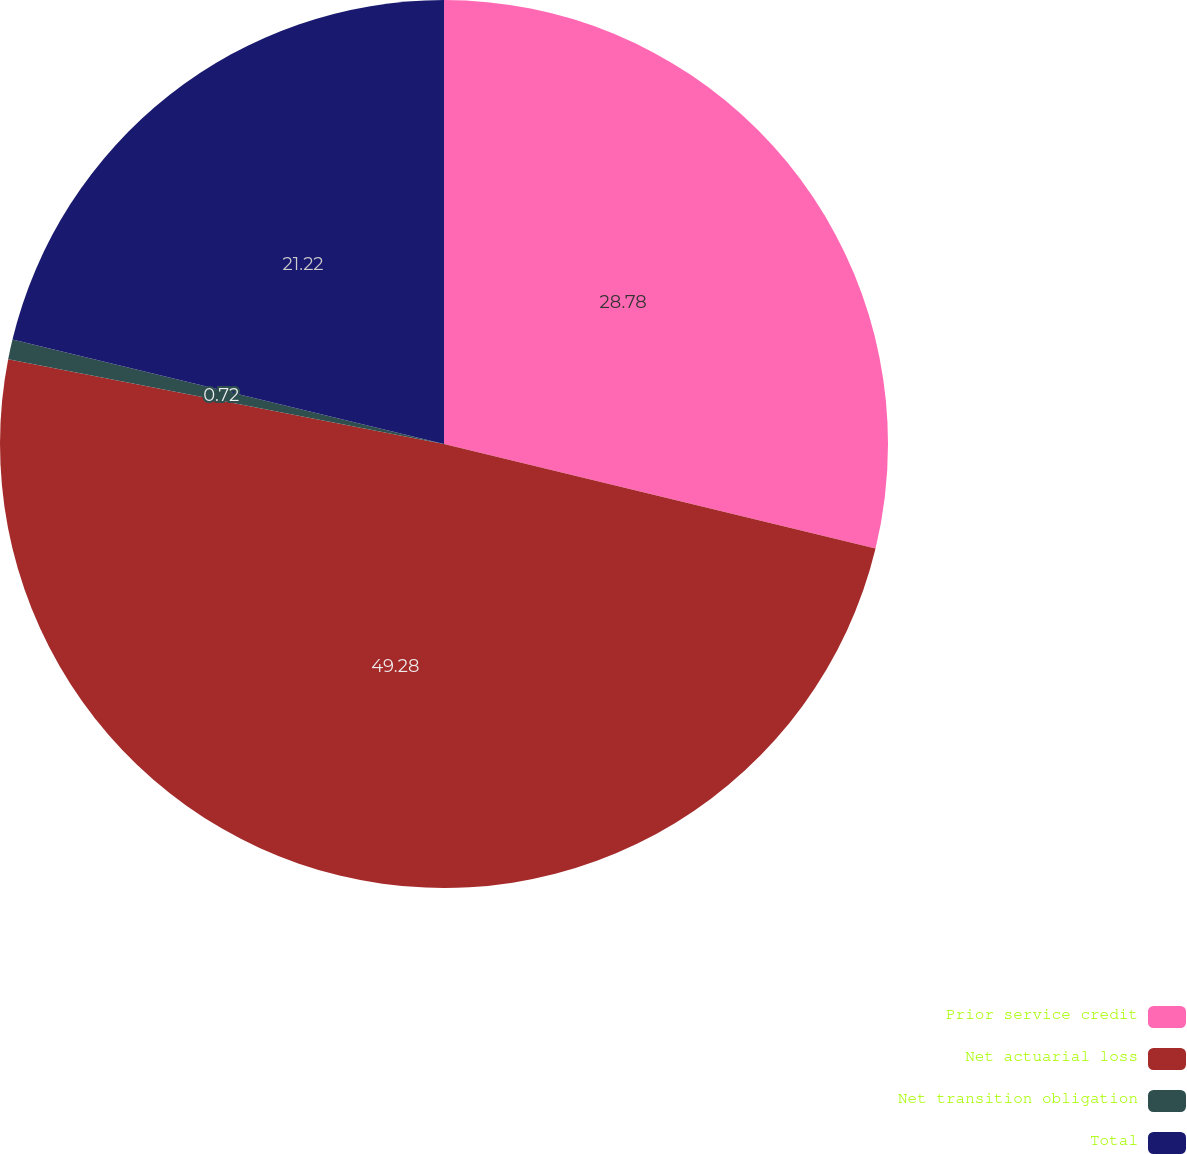Convert chart to OTSL. <chart><loc_0><loc_0><loc_500><loc_500><pie_chart><fcel>Prior service credit<fcel>Net actuarial loss<fcel>Net transition obligation<fcel>Total<nl><fcel>28.78%<fcel>49.28%<fcel>0.72%<fcel>21.22%<nl></chart> 